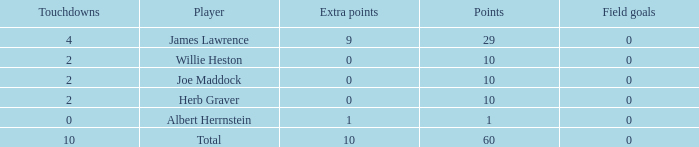What is the highest number of points for players with less than 2 touchdowns and 0 extra points? None. 